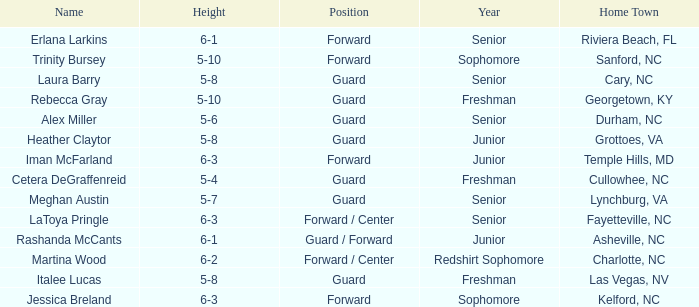What is the designation of the guard from cary, nc? Laura Barry. 